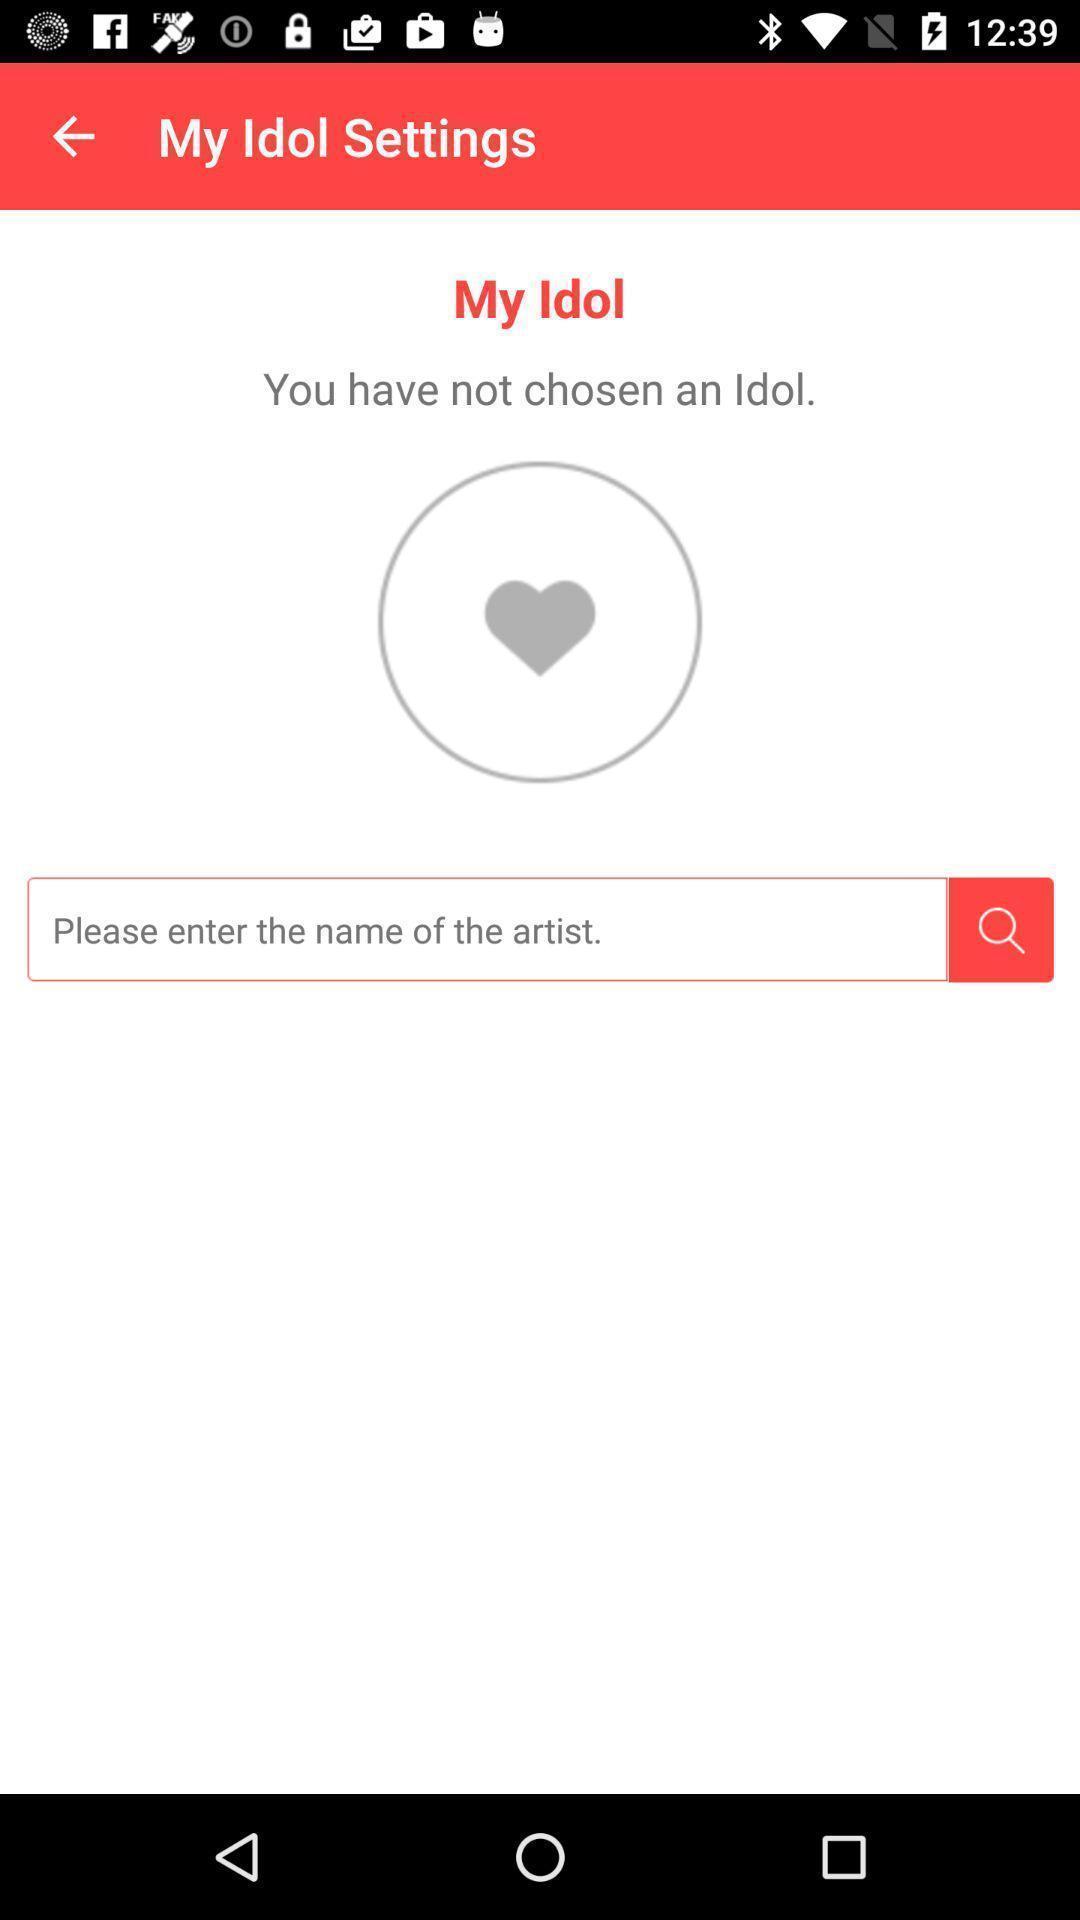Provide a description of this screenshot. Search page shows to enter the name of artist. 